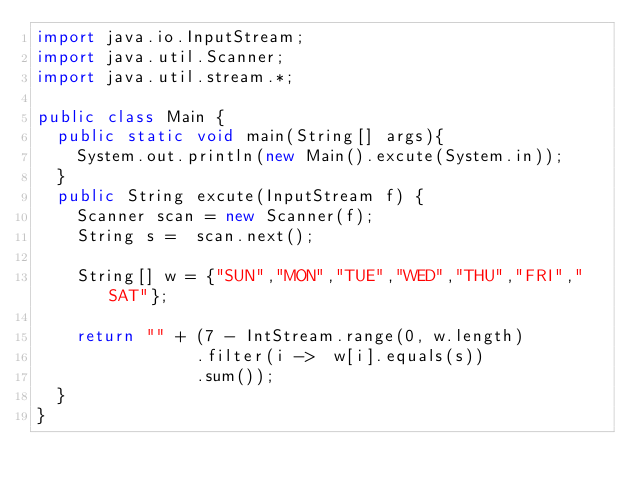Convert code to text. <code><loc_0><loc_0><loc_500><loc_500><_Java_>import java.io.InputStream;
import java.util.Scanner;
import java.util.stream.*;

public class Main {
  public static void main(String[] args){
    System.out.println(new Main().excute(System.in)); 
  }
  public String excute(InputStream f) {
    Scanner scan = new Scanner(f);
    String s =  scan.next();

    String[] w = {"SUN","MON","TUE","WED","THU","FRI","SAT"};

    return "" + (7 - IntStream.range(0, w.length)
                .filter(i ->  w[i].equals(s))
                .sum());
  }
}
</code> 